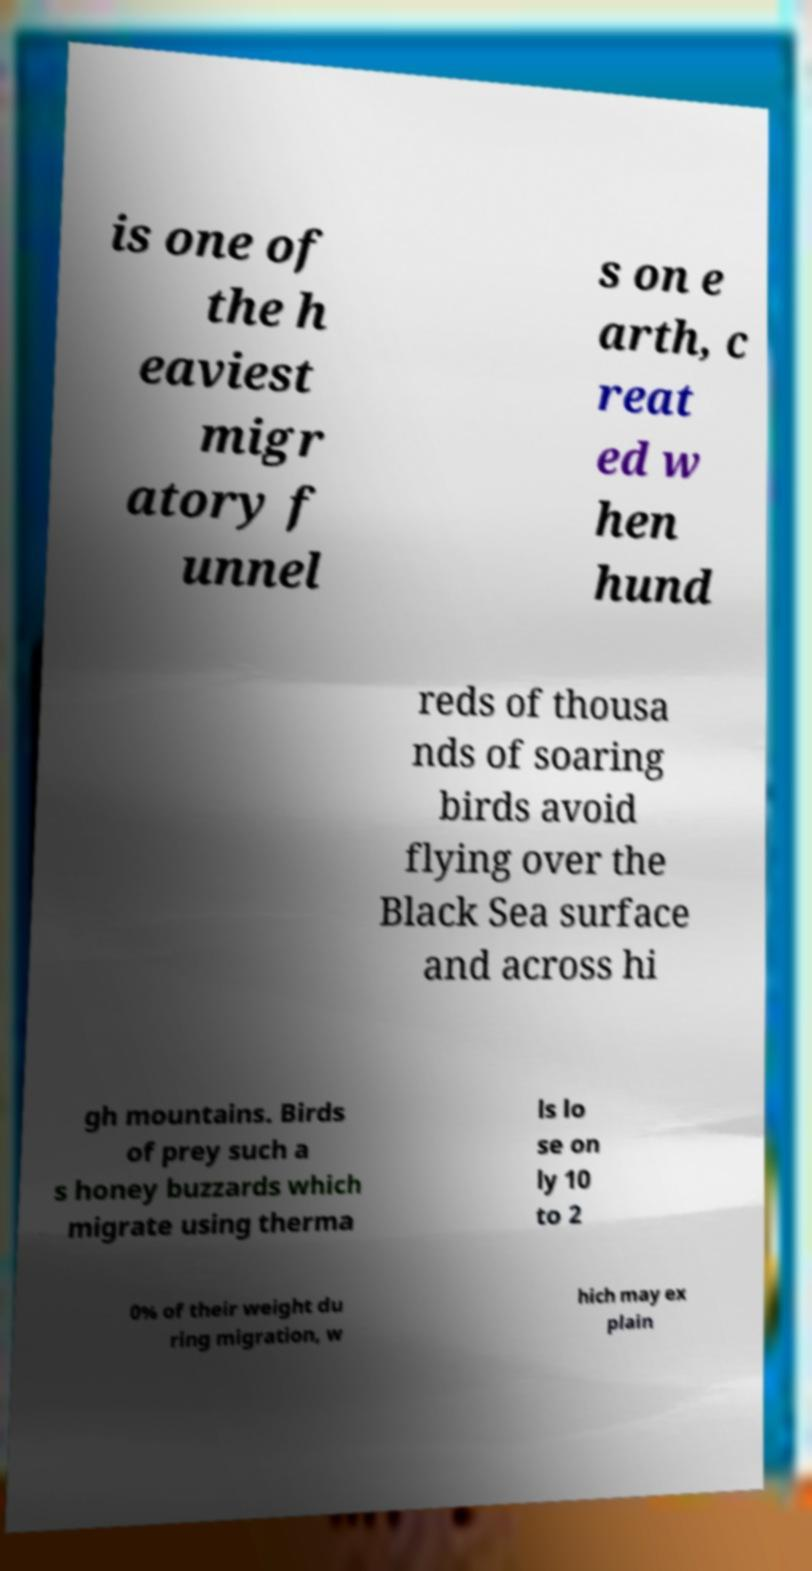I need the written content from this picture converted into text. Can you do that? is one of the h eaviest migr atory f unnel s on e arth, c reat ed w hen hund reds of thousa nds of soaring birds avoid flying over the Black Sea surface and across hi gh mountains. Birds of prey such a s honey buzzards which migrate using therma ls lo se on ly 10 to 2 0% of their weight du ring migration, w hich may ex plain 